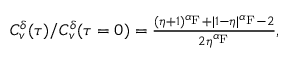<formula> <loc_0><loc_0><loc_500><loc_500>\begin{array} { r } { C _ { v } ^ { \delta } ( \tau ) / C _ { v } ^ { \delta } ( \tau = 0 ) = \frac { ( \eta + 1 ) ^ { \alpha _ { F } } + | 1 - \eta | ^ { \alpha _ { F } } - 2 } { 2 \eta ^ { \alpha _ { F } } } , } \end{array}</formula> 